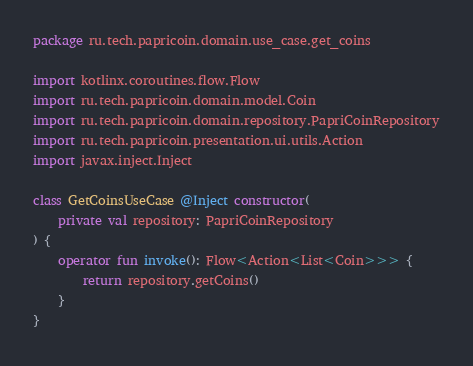<code> <loc_0><loc_0><loc_500><loc_500><_Kotlin_>package ru.tech.papricoin.domain.use_case.get_coins

import kotlinx.coroutines.flow.Flow
import ru.tech.papricoin.domain.model.Coin
import ru.tech.papricoin.domain.repository.PapriCoinRepository
import ru.tech.papricoin.presentation.ui.utils.Action
import javax.inject.Inject

class GetCoinsUseCase @Inject constructor(
    private val repository: PapriCoinRepository
) {
    operator fun invoke(): Flow<Action<List<Coin>>> {
        return repository.getCoins()
    }
}</code> 